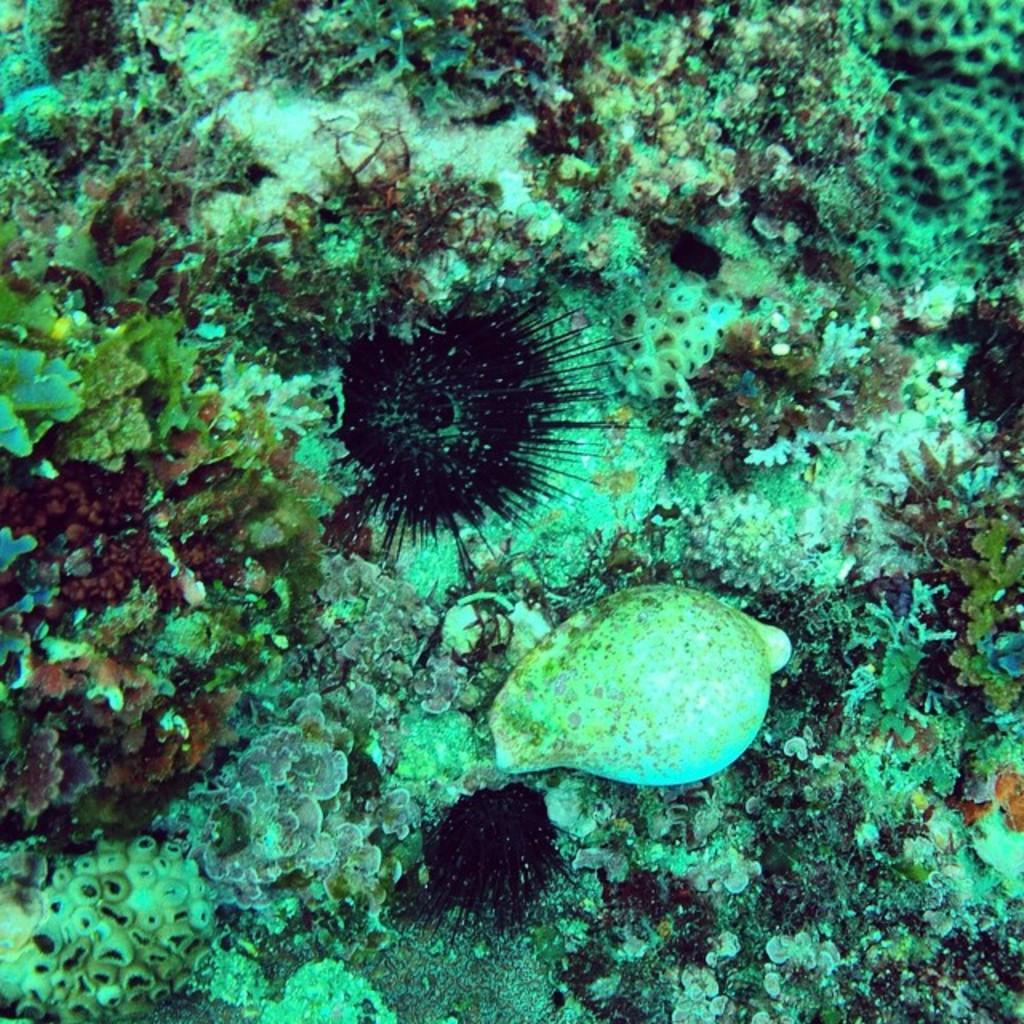Where was the image taken? The image was taken underwater. What type of vegetation can be seen in the image? There are marine plants visible in the image. What type of apparel is the person wearing in the image? There is no person visible in the image, as it was taken underwater and only marine plants can be seen. 